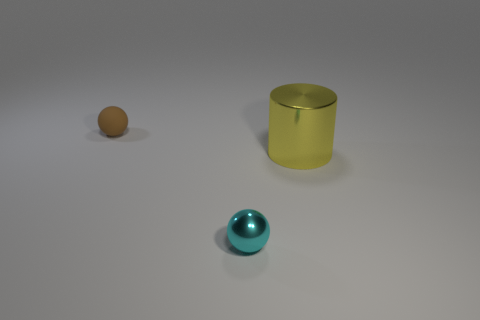Is there anything else that has the same size as the yellow cylinder?
Give a very brief answer. No. Are there any other things that are the same material as the brown thing?
Keep it short and to the point. No. Are there more cyan metallic balls than green cylinders?
Provide a succinct answer. Yes. Does the tiny object that is to the left of the cyan object have the same color as the cylinder?
Keep it short and to the point. No. The big thing is what color?
Your answer should be compact. Yellow. There is a thing on the right side of the tiny cyan object; are there any brown things right of it?
Give a very brief answer. No. The tiny object that is behind the tiny thing in front of the big metal object is what shape?
Your answer should be very brief. Sphere. Are there fewer cyan shiny things than metallic things?
Your response must be concise. Yes. Is the large cylinder made of the same material as the small cyan sphere?
Your answer should be compact. Yes. What is the color of the thing that is on the right side of the brown matte thing and left of the big yellow object?
Give a very brief answer. Cyan. 